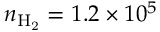<formula> <loc_0><loc_0><loc_500><loc_500>n _ { H _ { 2 } } = 1 . 2 \times 1 0 ^ { 5 }</formula> 